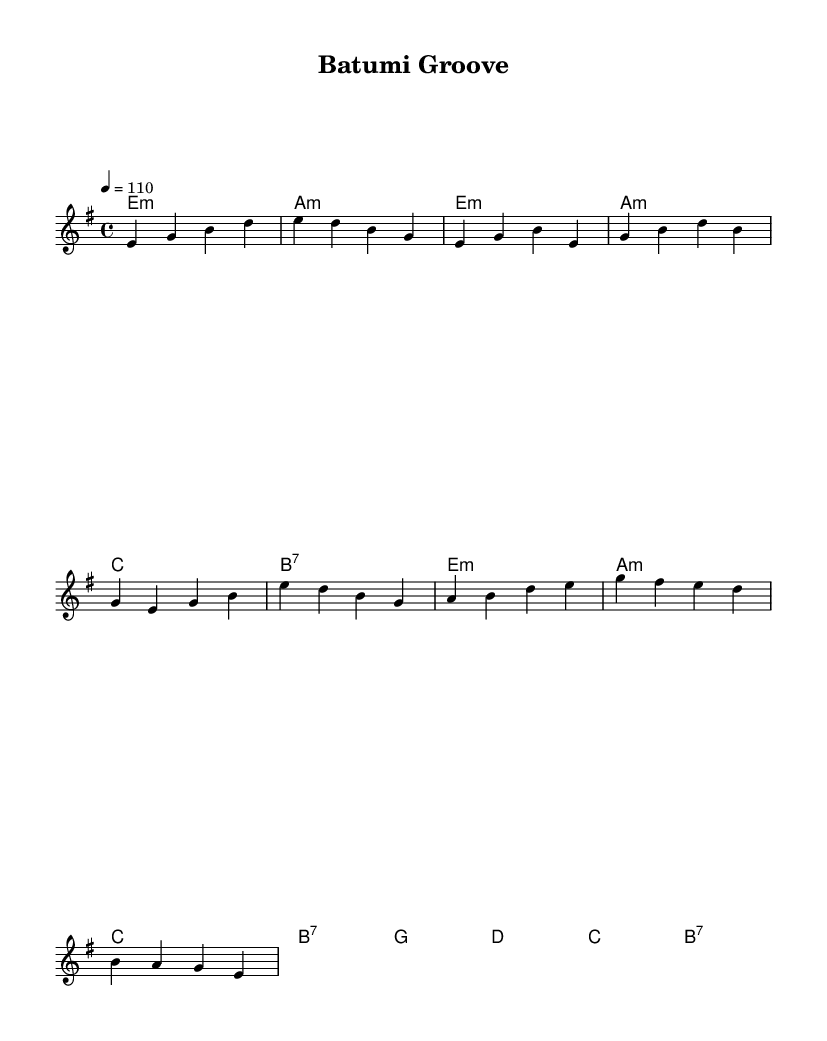What is the key signature of this music? The key signature is E minor, which has one sharp (F#).
Answer: E minor What is the time signature of this piece? The time signature is 4/4, indicating four beats per measure.
Answer: 4/4 What is the tempo marking for this piece? The tempo marking indicates a speed of 110 beats per minute.
Answer: 110 How many measures are in the chorus section? The chorus section consists of two measures in total.
Answer: 2 What chord comes after the C major in the verse? The chord following C major in the verse is B7, which is a dominant seventh chord.
Answer: B7 What style of music does this sheet represent? The style represented in this sheet music is Funk with a blend of retro Soviet-era influences and modern techniques.
Answer: Funk How many notes are in the bridge section? The bridge section contains eight notes in total.
Answer: 8 